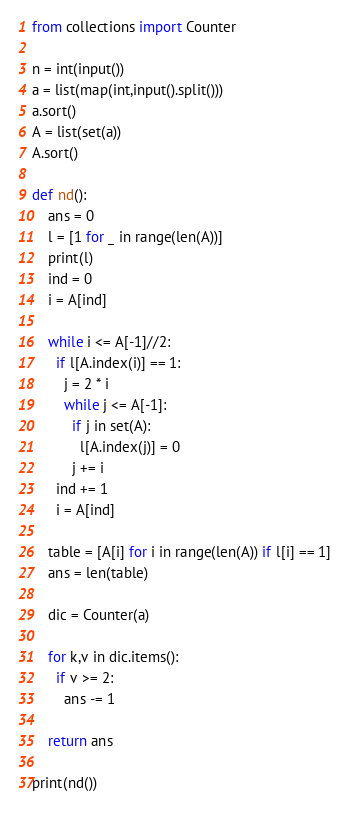Convert code to text. <code><loc_0><loc_0><loc_500><loc_500><_Python_>from collections import Counter

n = int(input())
a = list(map(int,input().split()))
a.sort()
A = list(set(a))
A.sort()

def nd():
    ans = 0
    l = [1 for _ in range(len(A))]
    print(l)
    ind = 0
    i = A[ind]
    
    while i <= A[-1]//2:
      if l[A.index(i)] == 1:
        j = 2 * i
        while j <= A[-1]:
          if j in set(A):
            l[A.index(j)] = 0
          j += i
      ind += 1
      i = A[ind]
          
    table = [A[i] for i in range(len(A)) if l[i] == 1]
    ans = len(table)
    
    dic = Counter(a)
    
    for k,v in dic.items():
      if v >= 2:
        ans -= 1
        
    return ans
  
print(nd())</code> 